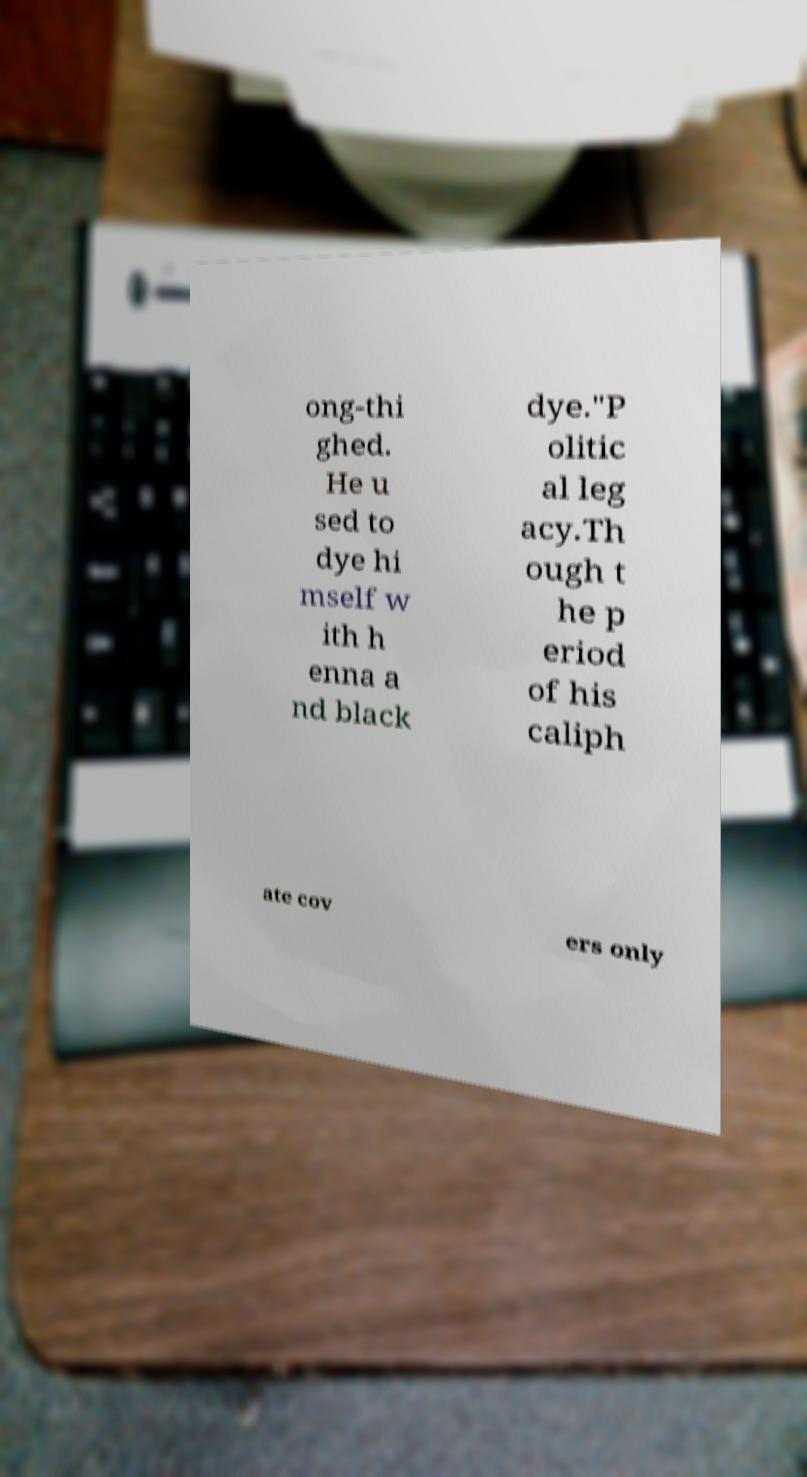Could you extract and type out the text from this image? ong-thi ghed. He u sed to dye hi mself w ith h enna a nd black dye."P olitic al leg acy.Th ough t he p eriod of his caliph ate cov ers only 